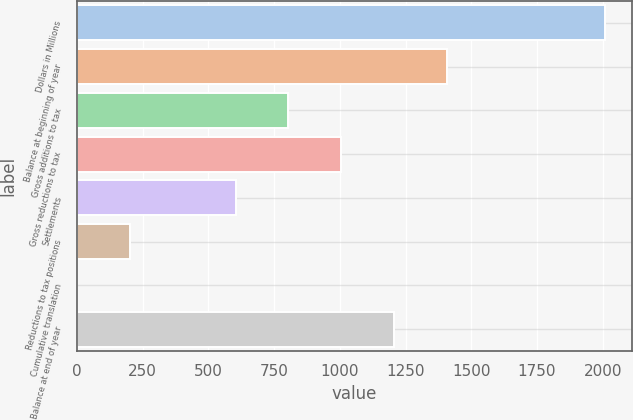<chart> <loc_0><loc_0><loc_500><loc_500><bar_chart><fcel>Dollars in Millions<fcel>Balance at beginning of year<fcel>Gross additions to tax<fcel>Gross reductions to tax<fcel>Settlements<fcel>Reductions to tax positions<fcel>Cumulative translation<fcel>Balance at end of year<nl><fcel>2010<fcel>1407.3<fcel>804.6<fcel>1005.5<fcel>603.7<fcel>201.9<fcel>1<fcel>1206.4<nl></chart> 